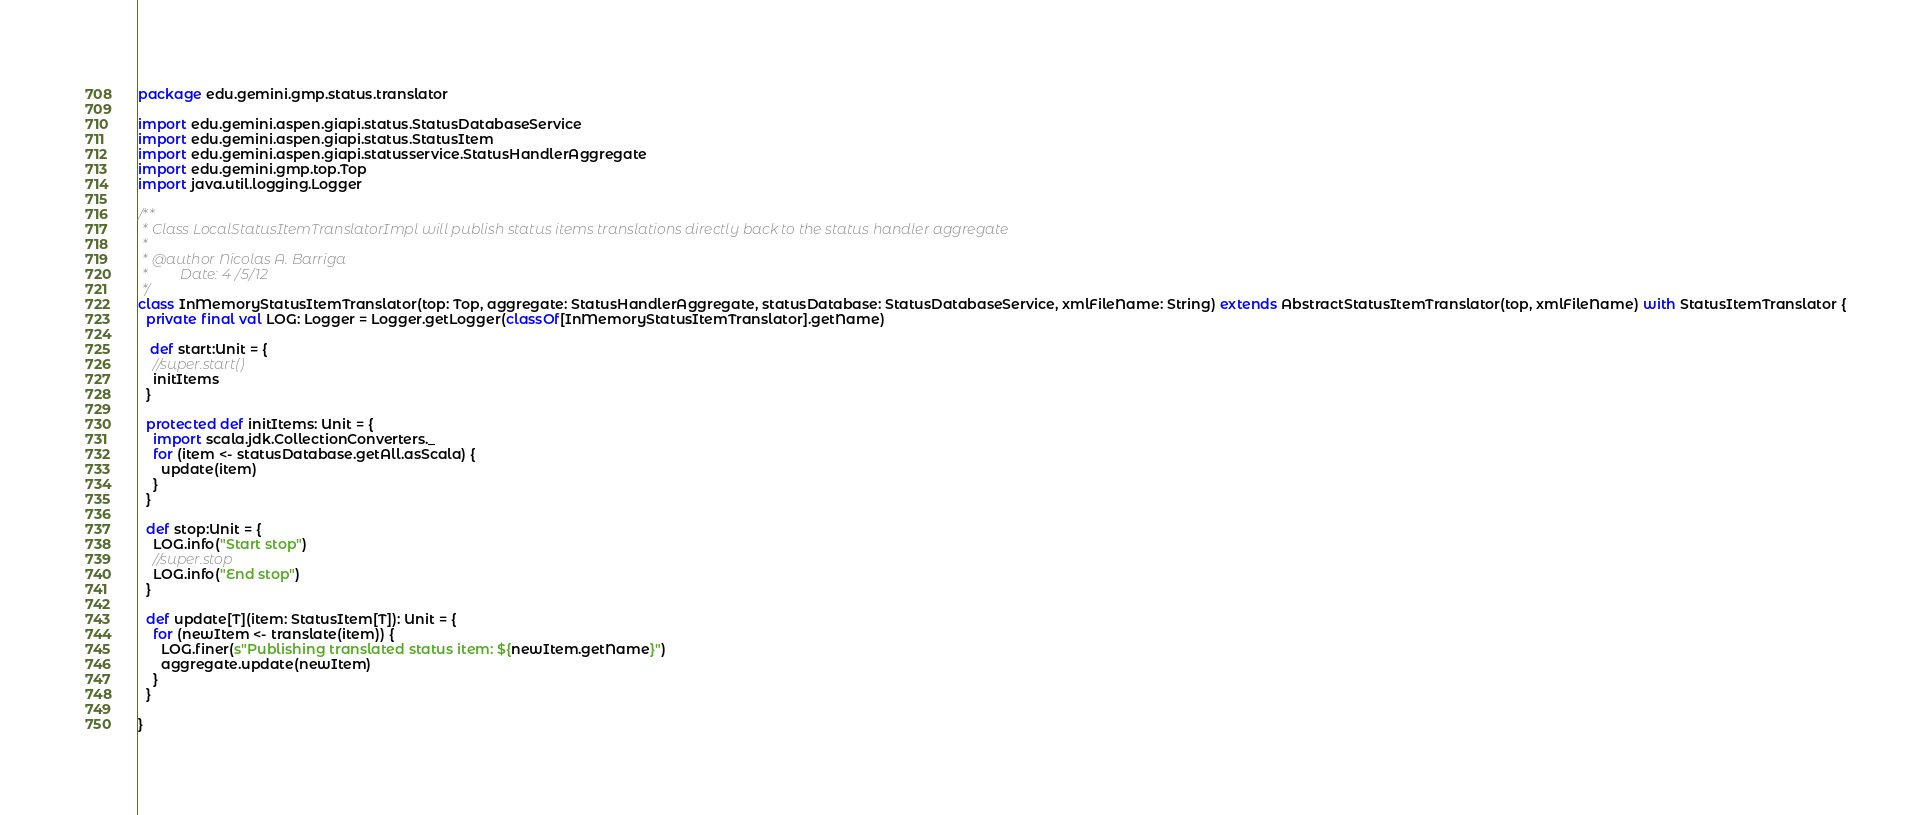<code> <loc_0><loc_0><loc_500><loc_500><_Scala_>package edu.gemini.gmp.status.translator

import edu.gemini.aspen.giapi.status.StatusDatabaseService
import edu.gemini.aspen.giapi.status.StatusItem
import edu.gemini.aspen.giapi.statusservice.StatusHandlerAggregate
import edu.gemini.gmp.top.Top
import java.util.logging.Logger

/**
 * Class LocalStatusItemTranslatorImpl will publish status items translations directly back to the status handler aggregate
 *
 * @author Nicolas A. Barriga
 *         Date: 4/5/12
 */
class InMemoryStatusItemTranslator(top: Top, aggregate: StatusHandlerAggregate, statusDatabase: StatusDatabaseService, xmlFileName: String) extends AbstractStatusItemTranslator(top, xmlFileName) with StatusItemTranslator {
  private final val LOG: Logger = Logger.getLogger(classOf[InMemoryStatusItemTranslator].getName)

   def start:Unit = {
    //super.start()
    initItems
  }

  protected def initItems: Unit = {
    import scala.jdk.CollectionConverters._
    for (item <- statusDatabase.getAll.asScala) {
      update(item)
    }
  }

  def stop:Unit = {
    LOG.info("Start stop")
    //super.stop
    LOG.info("End stop")
  }

  def update[T](item: StatusItem[T]): Unit = {
    for (newItem <- translate(item)) {
      LOG.finer(s"Publishing translated status item: ${newItem.getName}")
      aggregate.update(newItem)
    }
  }

}</code> 